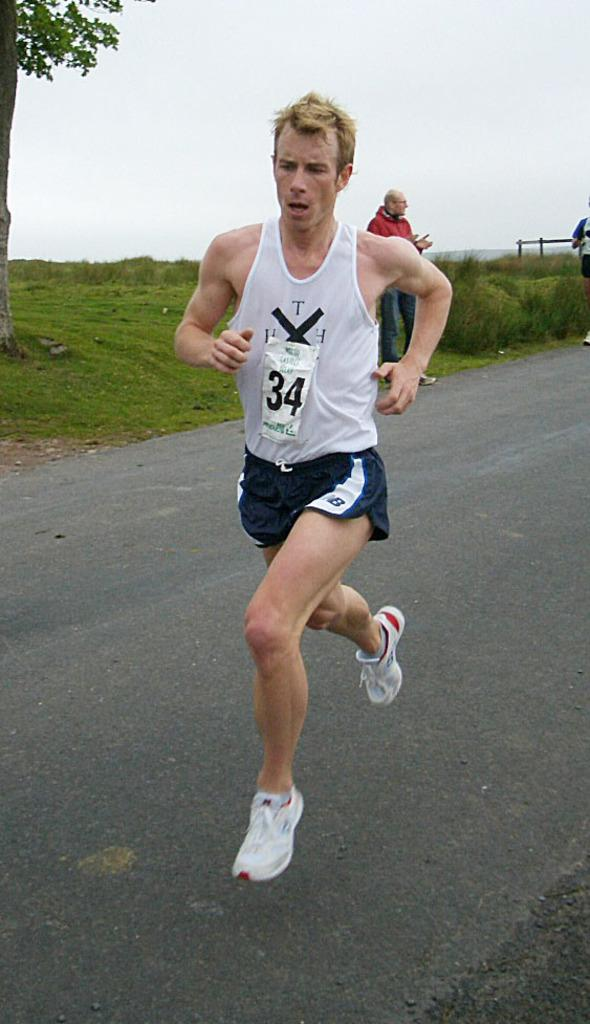<image>
Share a concise interpretation of the image provided. Runner #34 wears blue NB shorts and white shoes. 